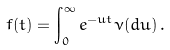Convert formula to latex. <formula><loc_0><loc_0><loc_500><loc_500>f ( t ) = \int _ { 0 } ^ { \infty } e ^ { - u t } \nu ( d u ) \, .</formula> 